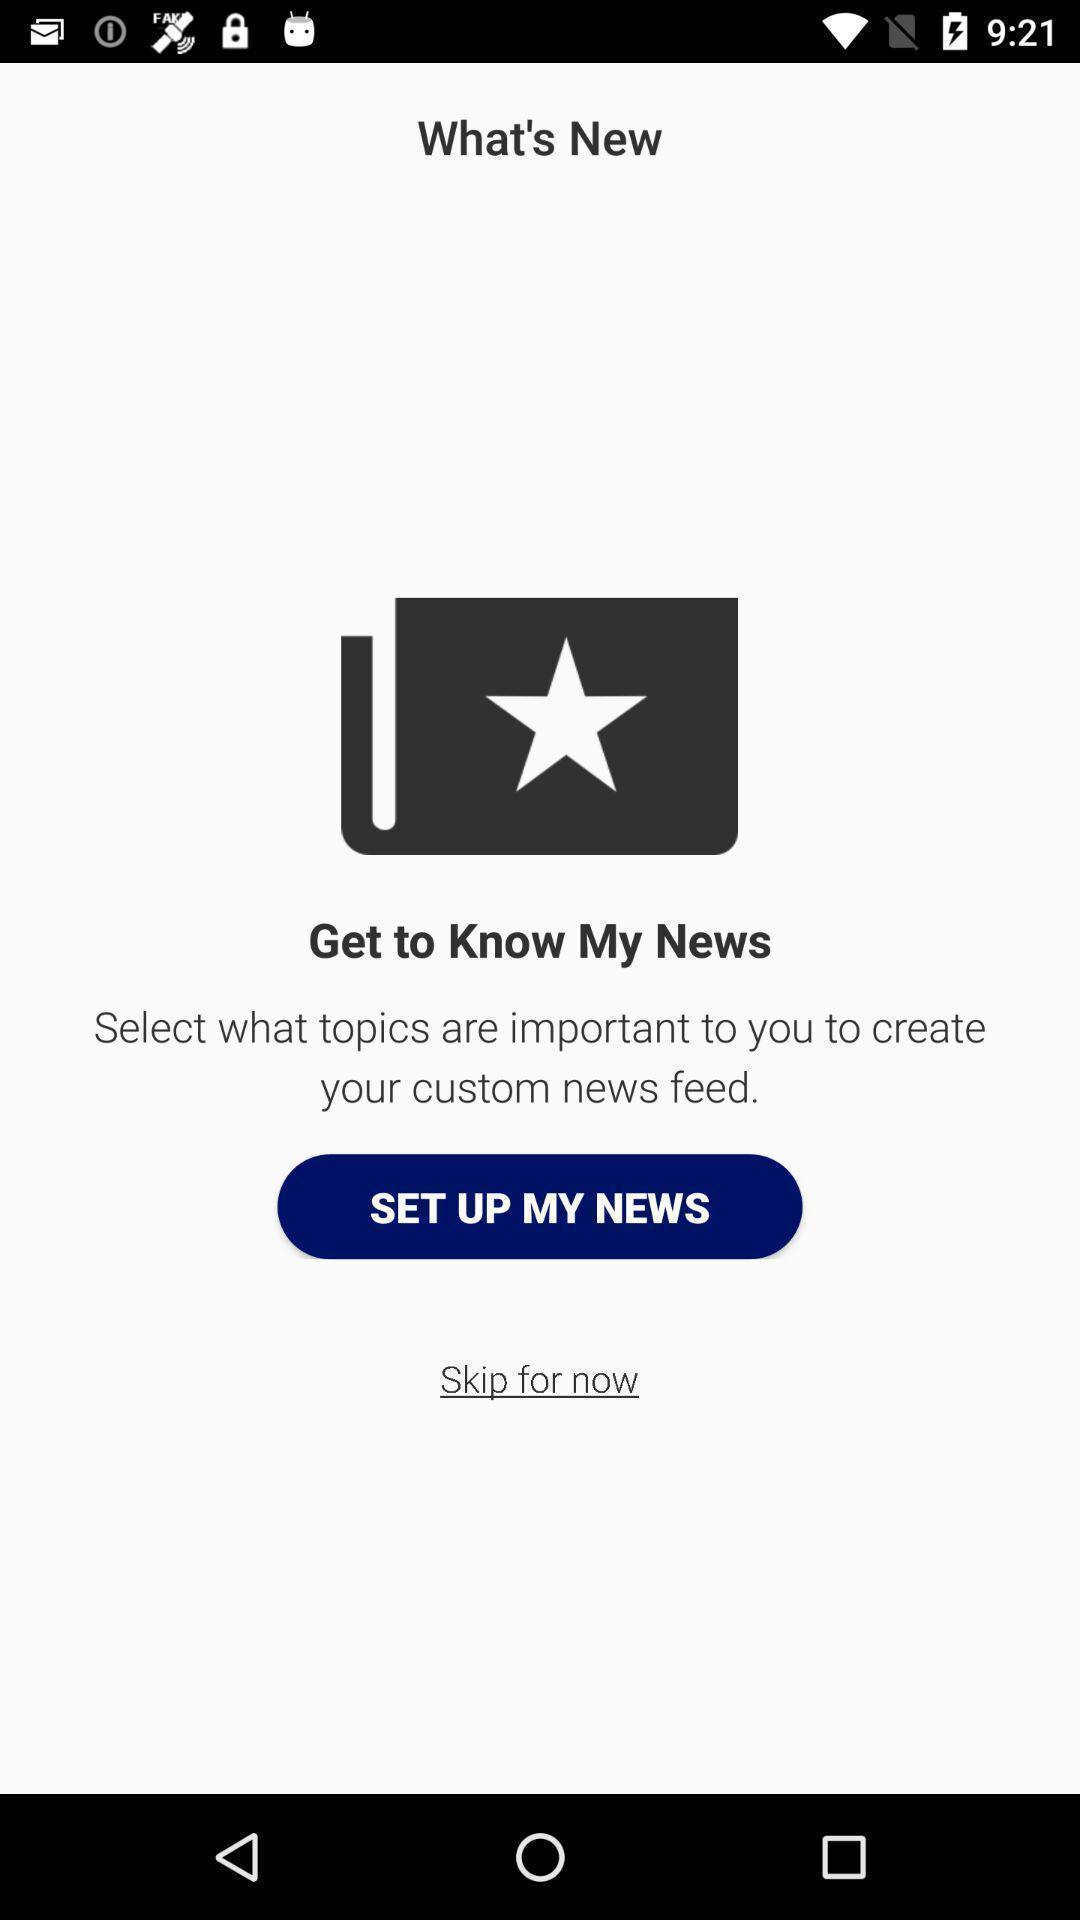Provide a detailed account of this screenshot. Page shows setup option for new things in news application. 